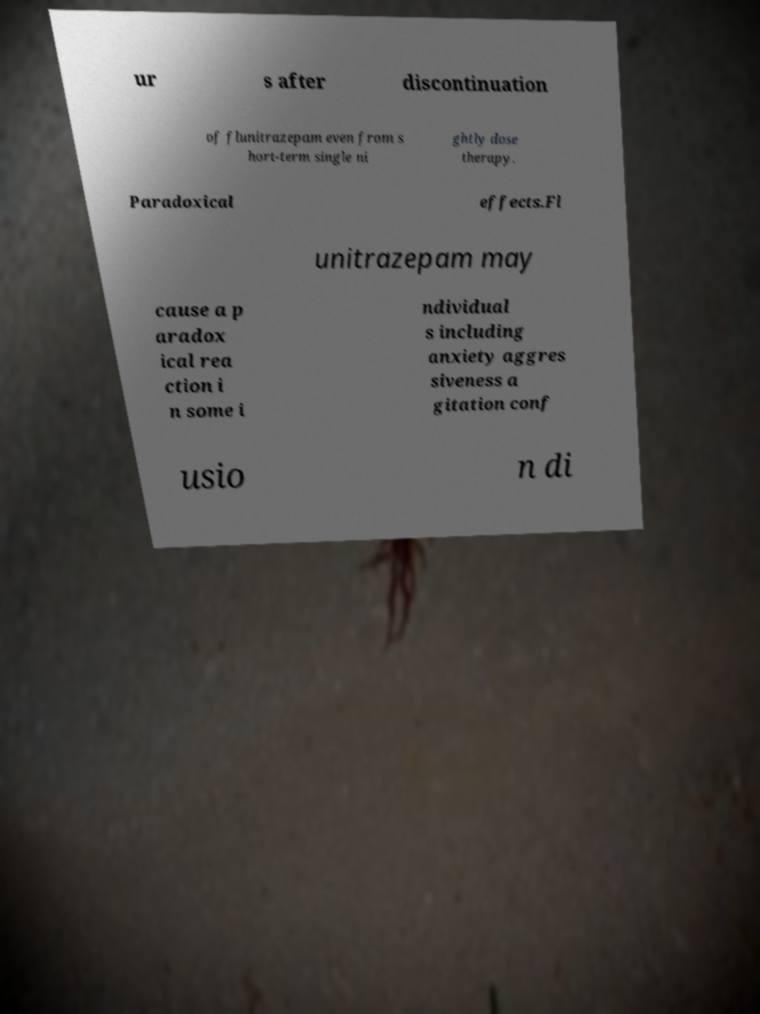Please identify and transcribe the text found in this image. ur s after discontinuation of flunitrazepam even from s hort-term single ni ghtly dose therapy. Paradoxical effects.Fl unitrazepam may cause a p aradox ical rea ction i n some i ndividual s including anxiety aggres siveness a gitation conf usio n di 